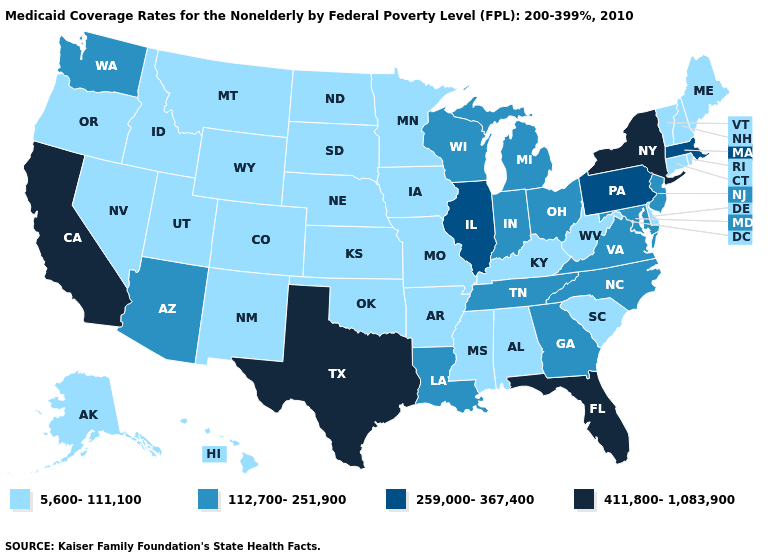How many symbols are there in the legend?
Quick response, please. 4. Which states have the lowest value in the South?
Answer briefly. Alabama, Arkansas, Delaware, Kentucky, Mississippi, Oklahoma, South Carolina, West Virginia. Does Washington have a higher value than South Dakota?
Be succinct. Yes. What is the highest value in states that border Nevada?
Write a very short answer. 411,800-1,083,900. What is the value of North Dakota?
Give a very brief answer. 5,600-111,100. Name the states that have a value in the range 112,700-251,900?
Concise answer only. Arizona, Georgia, Indiana, Louisiana, Maryland, Michigan, New Jersey, North Carolina, Ohio, Tennessee, Virginia, Washington, Wisconsin. Which states have the lowest value in the USA?
Give a very brief answer. Alabama, Alaska, Arkansas, Colorado, Connecticut, Delaware, Hawaii, Idaho, Iowa, Kansas, Kentucky, Maine, Minnesota, Mississippi, Missouri, Montana, Nebraska, Nevada, New Hampshire, New Mexico, North Dakota, Oklahoma, Oregon, Rhode Island, South Carolina, South Dakota, Utah, Vermont, West Virginia, Wyoming. What is the value of Virginia?
Give a very brief answer. 112,700-251,900. Does Virginia have the highest value in the South?
Give a very brief answer. No. Name the states that have a value in the range 259,000-367,400?
Concise answer only. Illinois, Massachusetts, Pennsylvania. Does Alabama have a lower value than Vermont?
Write a very short answer. No. Among the states that border West Virginia , which have the lowest value?
Concise answer only. Kentucky. Which states have the lowest value in the MidWest?
Keep it brief. Iowa, Kansas, Minnesota, Missouri, Nebraska, North Dakota, South Dakota. What is the value of Montana?
Answer briefly. 5,600-111,100. Name the states that have a value in the range 5,600-111,100?
Give a very brief answer. Alabama, Alaska, Arkansas, Colorado, Connecticut, Delaware, Hawaii, Idaho, Iowa, Kansas, Kentucky, Maine, Minnesota, Mississippi, Missouri, Montana, Nebraska, Nevada, New Hampshire, New Mexico, North Dakota, Oklahoma, Oregon, Rhode Island, South Carolina, South Dakota, Utah, Vermont, West Virginia, Wyoming. 